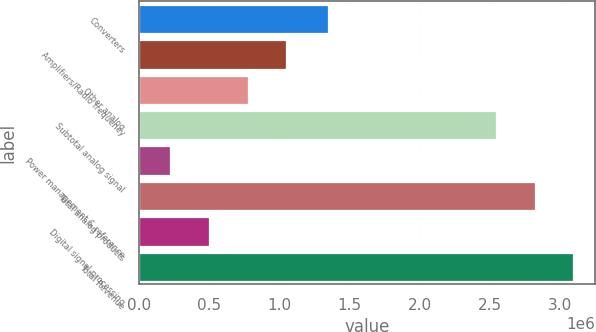Convert chart to OTSL. <chart><loc_0><loc_0><loc_500><loc_500><bar_chart><fcel>Converters<fcel>Amplifiers/Radio frequency<fcel>Other analog<fcel>Subtotal analog signal<fcel>Power management & reference<fcel>Total analog products<fcel>Digital signal processing<fcel>Total Revenue<nl><fcel>1.34349e+06<fcel>1.05033e+06<fcel>772756<fcel>2.54211e+06<fcel>217615<fcel>2.81968e+06<fcel>495186<fcel>3.09725e+06<nl></chart> 